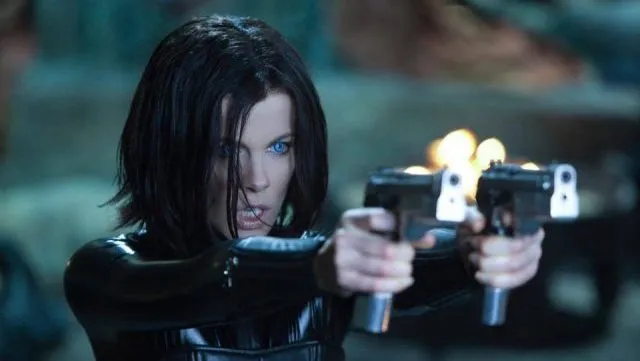What can you tell me about the mood and atmosphere depicted in this image? The mood in this image is foreboding and intense. The dark, blurry background combined with the blue lighting creates a cold and mysterious atmosphere. The character's fierce expression and poised stance suggest readiness for imminent action or conflict, adding a sense of urgency and tension. What does the character's outfit suggest about her personality or role? The black leather outfit is a strong indicator of the character's tough and resilient personality. It suggests that she is a warrior or fighter, ready to take on any challenges. The sleek and form-fitting design also implies agility and strength, characteristics essential for a combatant in a dark and perilous environment. How might the blue lighting affect the viewer's perception of this scene? The blue lighting lends a cold, almost supernatural feel to the scene. It enhances the sense of danger and otherworldliness, making the viewer perceive the character as someone who operates in a realm beyond normal human experiences. This visual cue aligns well with the Underworld universe, where mystical and dark elements are at play. Imagine an entirely different setting for the character. How would you describe her in a serene, peaceful environment? In a serene, peaceful environment, the character would appear quite out of place. Imagine her standing in a sunlit meadow, with her black leather outfit starkly contrasting the vibrant greens and yellows around her. Her intense expression might soften slightly, and the guns might be replaced by a calm, contemplative pose. The scene’s tranquility would juxtapose her usual fierce demeanor, highlighting her adaptability and depth as a character who is more than just a warrior. Can you construct a short plot for a story where she transitions from a dark world to a peaceful one? After centuries of battling in the shadows, Selene stumbles upon a mysterious portal that transports her to an otherworldly, serene realm. This new world, filled with lush greenery and harmonious wildlife, stands in stark contrast to the grim darkness she once knew. As Selene navigates this peaceful landscape, she gradually learns to let go of her past battles and finds solace in the tranquility around her. Her transition is not easy, and her warrior instincts are challenged by the need to protect this fragile peace from new, unseen threats. Ultimately, she becomes a guardian of this new world, blending her fierce protective nature with the newfound calmness, thus achieving inner peace while safeguarding her new home. 